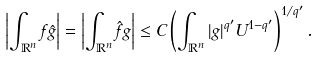Convert formula to latex. <formula><loc_0><loc_0><loc_500><loc_500>\left | \int _ { \mathbb { R } ^ { n } } f \hat { g } \right | = \left | \int _ { \mathbb { R } ^ { n } } \hat { f } g \right | \leq C \left ( \int _ { \mathbb { R } ^ { n } } | g | ^ { q ^ { \prime } } U ^ { 1 - q ^ { \prime } } \right ) ^ { 1 / q ^ { \prime } } .</formula> 